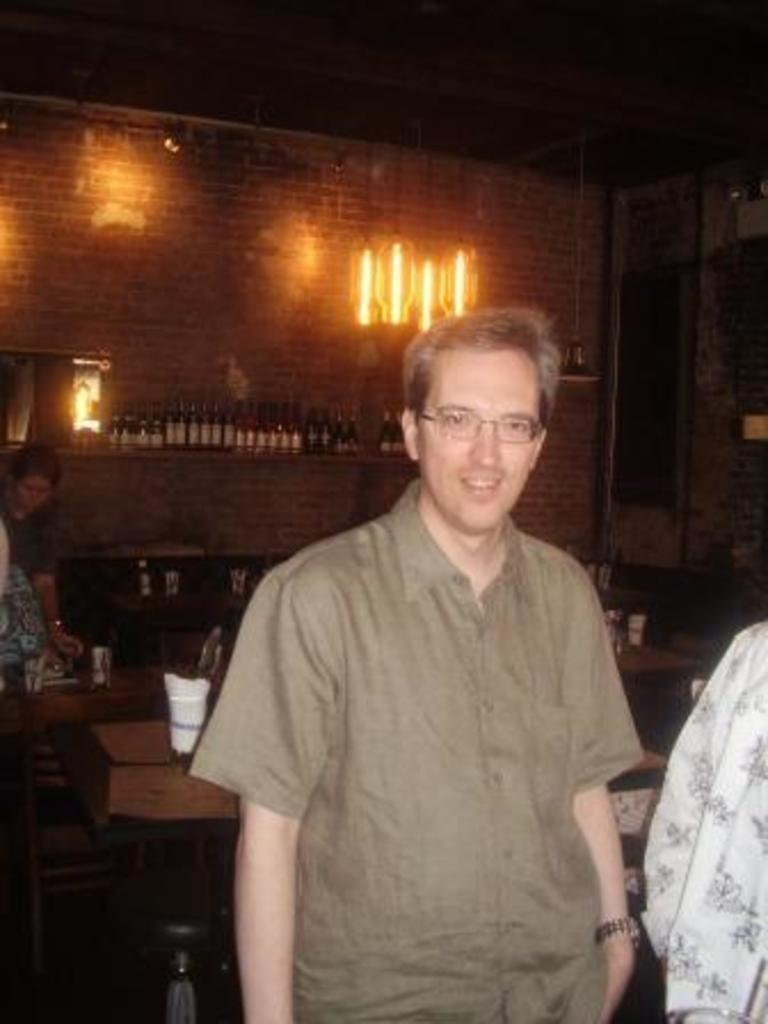What is the main subject of the image? There is a man in the image. Can you describe the man's appearance? The man is wearing spectacles. What is the man doing in the image? The man is standing and posing for a camera. Is there anyone else in the image? Yes, there is a woman behind the man. What objects can be seen in the image? There are chairs, a table, a bottle, and a lamp in the image. What type of poison is the man holding in the image? There is no poison present in the image; the man is holding a bottle, but its contents are not specified. 